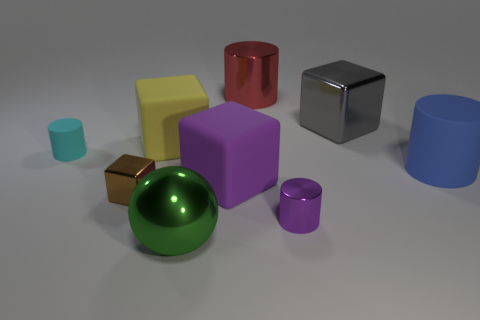There is a tiny metallic thing that is the same shape as the big gray thing; what color is it?
Your answer should be very brief. Brown. How many blocks are big purple matte things or blue matte things?
Provide a short and direct response. 1. How many large red metal cylinders are to the left of the rubber block to the left of the large object that is in front of the small block?
Provide a short and direct response. 0. There is a large cube that is the same color as the small shiny cylinder; what is its material?
Give a very brief answer. Rubber. Are there more tiny blue cylinders than green metallic objects?
Your response must be concise. No. Is the size of the shiny ball the same as the red thing?
Your response must be concise. Yes. How many objects are large brown balls or small rubber objects?
Provide a short and direct response. 1. What is the shape of the small shiny thing left of the large cylinder that is behind the large yellow rubber thing on the right side of the tiny cyan rubber object?
Ensure brevity in your answer.  Cube. Is the material of the small object that is to the right of the green shiny thing the same as the cylinder on the left side of the yellow cube?
Ensure brevity in your answer.  No. What is the material of the yellow object that is the same shape as the big gray shiny thing?
Provide a short and direct response. Rubber. 